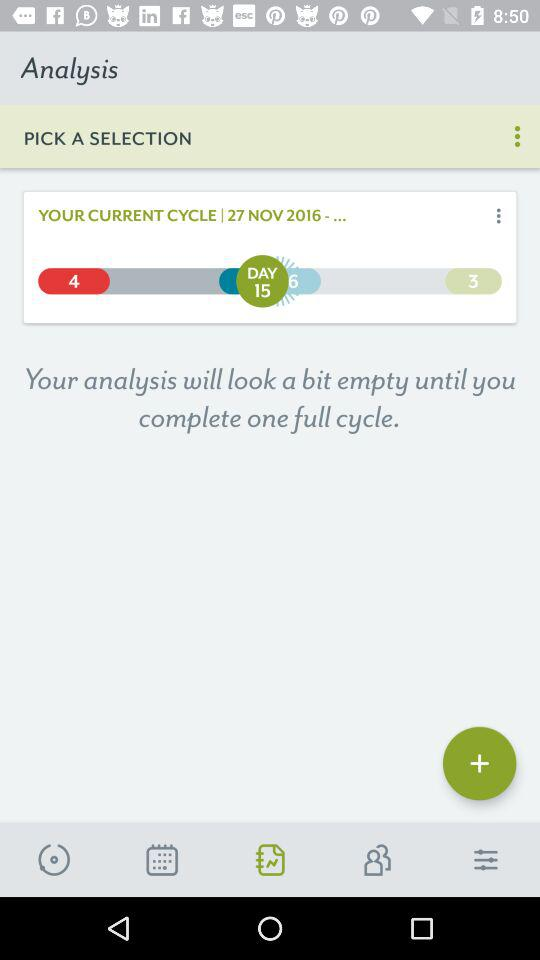What is the current cycle date? The current cycle date is November 27, 2016. 